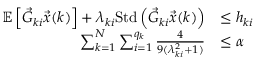<formula> <loc_0><loc_0><loc_500><loc_500>\begin{array} { r l } { \mathbb { E } \left [ \vec { G } _ { k i } \vec { x } ( k ) \right ] + \lambda _ { k i } S t d \left ( \vec { G } _ { k i } \vec { x } ( k ) \right ) } & { \leq h _ { k i } } \\ { \sum _ { k = 1 } ^ { N } \sum _ { i = 1 } ^ { q _ { k } } \frac { 4 } { 9 ( \lambda _ { k i } ^ { 2 } + 1 ) } } & { \leq \alpha } \end{array}</formula> 